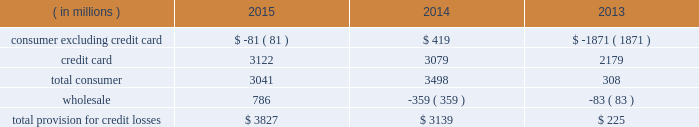Jpmorgan chase & co./2015 annual report 73 in advisory fees was driven by the combined impact of a greater share of fees for completed transactions , and growth in industry-wide fees .
The increase in equity underwriting fees was driven by higher industry-wide issuance .
The decrease in debt underwriting fees was primarily related to lower bond underwriting fees compared with the prior year , and lower loan syndication fees on lower industry-wide fees .
Principal transactions revenue increased as the prior year included a $ 1.5 billion loss related to the implementation of the funding valuation adjustment ( 201cfva 201d ) framework for over-the-counter ( 201cotc 201d ) derivatives and structured notes .
Private equity gains increased as a result of higher net gains on sales .
These increases were partially offset by lower fixed income markets revenue in cib , primarily driven by credit-related and rates products , as well as the impact of business simplification initiatives .
Lending- and deposit-related fees decreased compared with the prior year , reflecting the impact of business simplification initiatives and lower trade finance revenue in cib .
Asset management , administration and commissions revenue increased compared with the prior year , reflecting higher asset management fees driven by net client inflows and higher market levels in am and ccb .
The increase was offset partially by lower commissions and other fee revenue in ccb as a result of the exit of a non-core product in 2013 .
Securities gains decreased compared with the prior year , reflecting lower repositioning activity related to the firm 2019s investment securities portfolio .
Mortgage fees and related income decreased compared with the prior year , predominantly due to lower net production revenue driven by lower volumes due to higher mortgage interest rates , and tighter margins .
The decline in net production revenue was partially offset by a lower loss on the risk management of mortgage servicing rights ( 201cmsrs 201d ) .
Card income was relatively flat compared with the prior year , but included higher net interchange income due to growth in credit and debit card sales volume , offset by higher amortization of new account origination costs .
Other income decreased from the prior year , predominantly from the absence of two significant items recorded in corporate in 2013 : gains of $ 1.3 billion and $ 493 million from sales of visa shares and one chase manhattan plaza , respectively .
Lower valuations of seed capital investments in am and losses related to the exit of non-core portfolios in card also contributed to the decrease .
These items were partially offset by higher auto lease income as a result of growth in auto lease volume , and a benefit from a tax settlement .
Net interest income increased slightly from the prior year , predominantly reflecting higher yields on investment securities , the impact of lower interest expense from lower rates , and higher average loan balances .
The increase was partially offset by lower yields on loans due to the run-off of higher-yielding loans and new originations of lower-yielding loans , and lower average interest-earning trading asset balances .
The firm 2019s average interest-earning assets were $ 2.0 trillion , and the net interest yield on these assets , on a fte basis , was 2.18% ( 2.18 % ) , a decrease of 5 basis points from the prior year .
Provision for credit losses year ended december 31 .
2015 compared with 2014 the provision for credit losses increased from the prior year as a result of an increase in the wholesale provision , largely reflecting the impact of downgrades in the oil & gas portfolio .
The increase was partially offset by a decrease in the consumer provision , reflecting lower net charge-offs due to continued discipline in credit underwriting , as well as improvement in the economy driven by increasing home prices and lower unemployment levels .
The increase was partially offset by a lower reduction in the allowance for loan losses .
For a more detailed discussion of the credit portfolio and the allowance for credit losses , see the segment discussions of ccb on pages 85 201393 , cb on pages 99 2013101 , and the allowance for credit losses on pages 130 2013132 .
2014 compared with 2013 the provision for credit losses increased by $ 2.9 billion from the prior year as result of a lower benefit from reductions in the consumer allowance for loan losses , partially offset by lower net charge-offs .
The consumer allowance reduction in 2014 was primarily related to the consumer , excluding credit card , portfolio and reflected the continued improvement in home prices and delinquencies in the residential real estate portfolio .
The wholesale provision reflected a continued favorable credit environment. .
Without the wholesale provision in 2015 , what would the total loan loss provision have been? 
Computations: (3827 - 786)
Answer: 3041.0. 